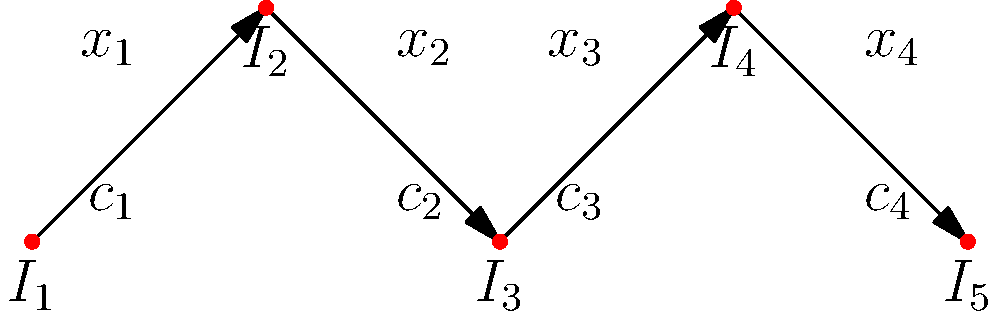As part of a neighborhood revitalization project, you're tasked with optimizing traffic flow through a series of intersections. The network is represented by the graph above, where $I_1$ to $I_5$ are intersections, $x_i$ represents the traffic flow on each road segment, and $c_i$ represents the capacity of each road segment. Given that the total inflow at $I_1$ equals the total outflow at $I_5$, and assuming conservation of flow at each intersection, what is the maximum possible flow through this network in terms of the capacities $c_i$? To solve this problem, we'll use the concept of maximum flow in a network. Here's a step-by-step approach:

1) In a flow network, the maximum flow is equal to the minimum cut capacity. This is known as the max-flow min-cut theorem.

2) In this linear network, any cut will consist of exactly one edge. Therefore, the minimum cut will be the edge with the smallest capacity.

3) The capacities of the edges are given as $c_1$, $c_2$, $c_3$, and $c_4$.

4) The conservation of flow principle states that the inflow must equal the outflow at each intersection (except the source and sink). This means that the flow through each edge must be the same for the maximum flow to be achieved.

5) If we try to push more flow than the minimum capacity, it will be blocked at the edge with this capacity, and the excess flow will have to be reduced at previous edges to maintain conservation of flow.

6) Therefore, the maximum flow through the entire network will be limited by the edge with the smallest capacity.

7) We can express this mathematically as:

   $$\text{Maximum Flow} = \min(c_1, c_2, c_3, c_4)$$

This solution ensures that we're utilizing the full capacity of the network while respecting the constraints of conservation of flow and edge capacities.
Answer: $\min(c_1, c_2, c_3, c_4)$ 